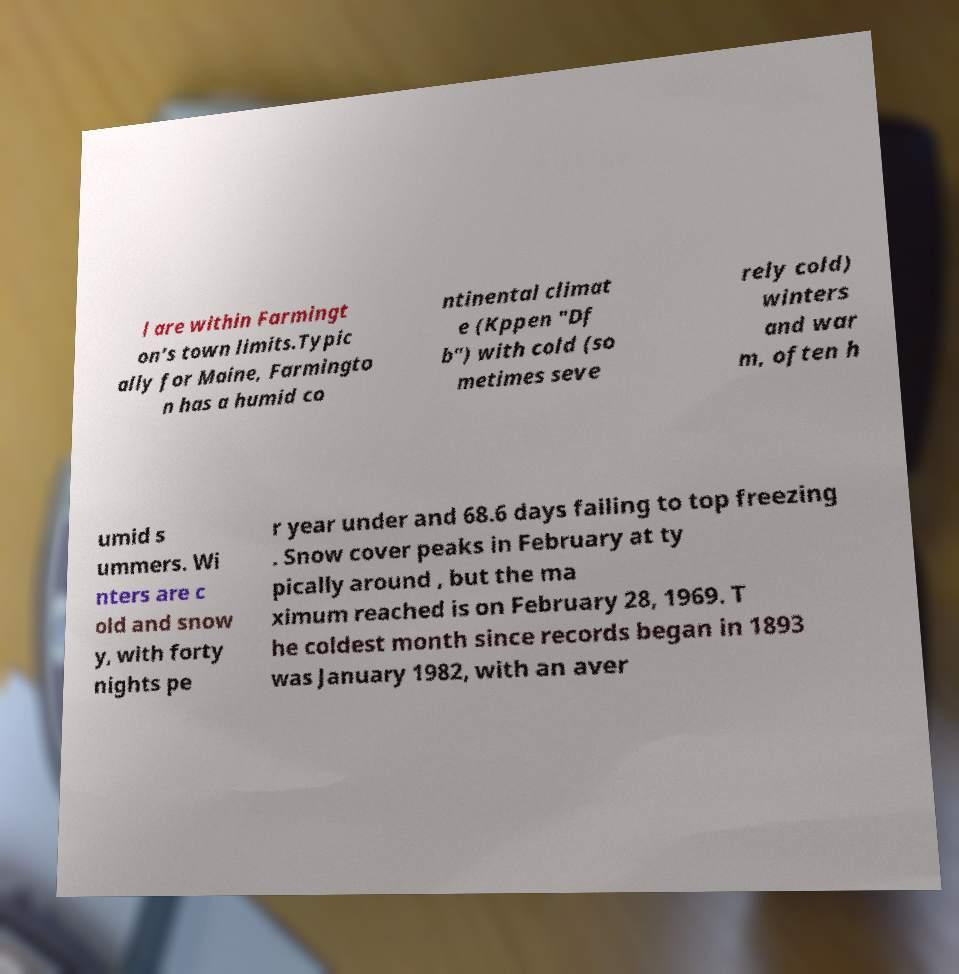Could you extract and type out the text from this image? l are within Farmingt on's town limits.Typic ally for Maine, Farmingto n has a humid co ntinental climat e (Kppen "Df b") with cold (so metimes seve rely cold) winters and war m, often h umid s ummers. Wi nters are c old and snow y, with forty nights pe r year under and 68.6 days failing to top freezing . Snow cover peaks in February at ty pically around , but the ma ximum reached is on February 28, 1969. T he coldest month since records began in 1893 was January 1982, with an aver 